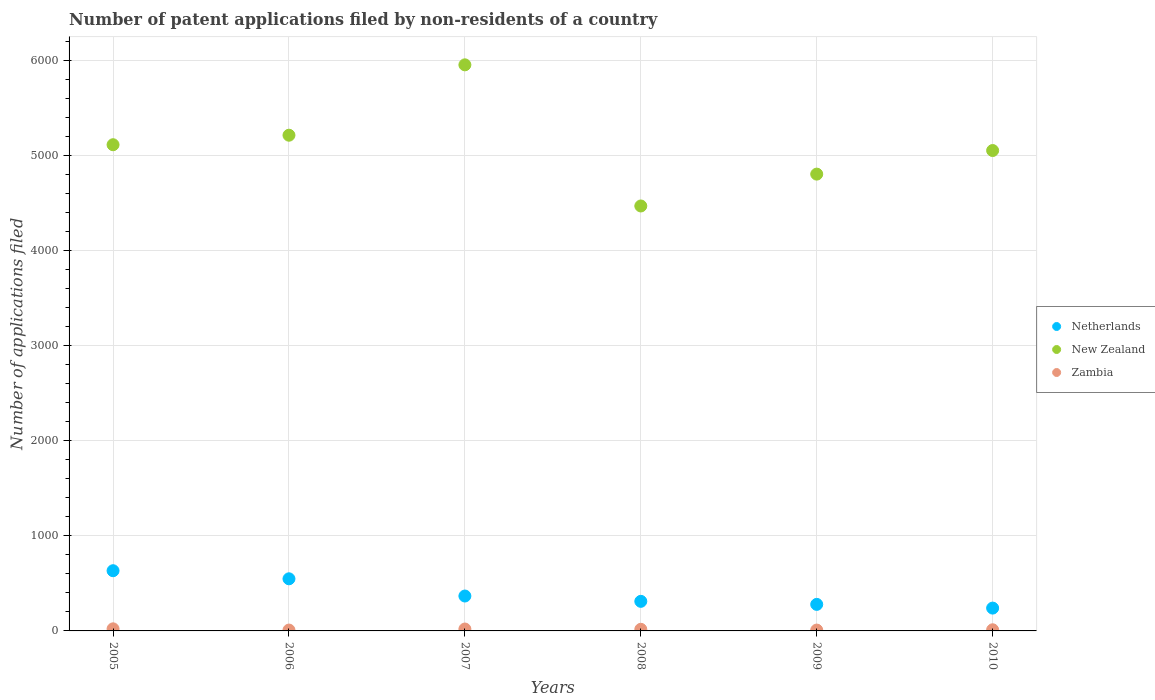Is the number of dotlines equal to the number of legend labels?
Offer a very short reply. Yes. What is the number of applications filed in New Zealand in 2005?
Provide a short and direct response. 5112. Across all years, what is the maximum number of applications filed in Netherlands?
Your answer should be compact. 633. Across all years, what is the minimum number of applications filed in Netherlands?
Provide a short and direct response. 240. What is the total number of applications filed in Netherlands in the graph?
Keep it short and to the point. 2378. What is the difference between the number of applications filed in New Zealand in 2005 and that in 2006?
Offer a terse response. -100. What is the difference between the number of applications filed in New Zealand in 2008 and the number of applications filed in Netherlands in 2007?
Give a very brief answer. 4101. What is the average number of applications filed in New Zealand per year?
Your answer should be compact. 5099.67. In the year 2009, what is the difference between the number of applications filed in Netherlands and number of applications filed in Zambia?
Give a very brief answer. 270. In how many years, is the number of applications filed in Zambia greater than 600?
Your answer should be very brief. 0. What is the ratio of the number of applications filed in Zambia in 2006 to that in 2010?
Your response must be concise. 0.75. What is the difference between the highest and the lowest number of applications filed in Netherlands?
Keep it short and to the point. 393. Is it the case that in every year, the sum of the number of applications filed in Zambia and number of applications filed in New Zealand  is greater than the number of applications filed in Netherlands?
Offer a very short reply. Yes. Does the number of applications filed in Netherlands monotonically increase over the years?
Offer a very short reply. No. Is the number of applications filed in Netherlands strictly less than the number of applications filed in Zambia over the years?
Provide a succinct answer. No. Are the values on the major ticks of Y-axis written in scientific E-notation?
Ensure brevity in your answer.  No. Does the graph contain any zero values?
Ensure brevity in your answer.  No. Does the graph contain grids?
Provide a succinct answer. Yes. How are the legend labels stacked?
Give a very brief answer. Vertical. What is the title of the graph?
Your answer should be compact. Number of patent applications filed by non-residents of a country. Does "Eritrea" appear as one of the legend labels in the graph?
Your answer should be compact. No. What is the label or title of the X-axis?
Provide a succinct answer. Years. What is the label or title of the Y-axis?
Give a very brief answer. Number of applications filed. What is the Number of applications filed in Netherlands in 2005?
Make the answer very short. 633. What is the Number of applications filed in New Zealand in 2005?
Your answer should be very brief. 5112. What is the Number of applications filed of Zambia in 2005?
Give a very brief answer. 22. What is the Number of applications filed in Netherlands in 2006?
Keep it short and to the point. 548. What is the Number of applications filed in New Zealand in 2006?
Provide a succinct answer. 5212. What is the Number of applications filed in Netherlands in 2007?
Your answer should be very brief. 367. What is the Number of applications filed of New Zealand in 2007?
Provide a succinct answer. 5952. What is the Number of applications filed in Zambia in 2007?
Keep it short and to the point. 20. What is the Number of applications filed of Netherlands in 2008?
Give a very brief answer. 311. What is the Number of applications filed of New Zealand in 2008?
Provide a short and direct response. 4468. What is the Number of applications filed in Zambia in 2008?
Provide a short and direct response. 17. What is the Number of applications filed in Netherlands in 2009?
Give a very brief answer. 279. What is the Number of applications filed of New Zealand in 2009?
Provide a short and direct response. 4803. What is the Number of applications filed in Netherlands in 2010?
Offer a very short reply. 240. What is the Number of applications filed of New Zealand in 2010?
Provide a succinct answer. 5051. Across all years, what is the maximum Number of applications filed in Netherlands?
Your answer should be compact. 633. Across all years, what is the maximum Number of applications filed of New Zealand?
Your response must be concise. 5952. Across all years, what is the maximum Number of applications filed in Zambia?
Your answer should be compact. 22. Across all years, what is the minimum Number of applications filed of Netherlands?
Provide a succinct answer. 240. Across all years, what is the minimum Number of applications filed of New Zealand?
Your response must be concise. 4468. What is the total Number of applications filed in Netherlands in the graph?
Provide a succinct answer. 2378. What is the total Number of applications filed of New Zealand in the graph?
Ensure brevity in your answer.  3.06e+04. What is the total Number of applications filed of Zambia in the graph?
Keep it short and to the point. 89. What is the difference between the Number of applications filed of Netherlands in 2005 and that in 2006?
Provide a succinct answer. 85. What is the difference between the Number of applications filed in New Zealand in 2005 and that in 2006?
Keep it short and to the point. -100. What is the difference between the Number of applications filed in Netherlands in 2005 and that in 2007?
Give a very brief answer. 266. What is the difference between the Number of applications filed of New Zealand in 2005 and that in 2007?
Your answer should be very brief. -840. What is the difference between the Number of applications filed of Netherlands in 2005 and that in 2008?
Offer a very short reply. 322. What is the difference between the Number of applications filed in New Zealand in 2005 and that in 2008?
Your answer should be very brief. 644. What is the difference between the Number of applications filed of Netherlands in 2005 and that in 2009?
Ensure brevity in your answer.  354. What is the difference between the Number of applications filed in New Zealand in 2005 and that in 2009?
Keep it short and to the point. 309. What is the difference between the Number of applications filed of Netherlands in 2005 and that in 2010?
Offer a terse response. 393. What is the difference between the Number of applications filed in Netherlands in 2006 and that in 2007?
Your answer should be very brief. 181. What is the difference between the Number of applications filed in New Zealand in 2006 and that in 2007?
Provide a succinct answer. -740. What is the difference between the Number of applications filed of Netherlands in 2006 and that in 2008?
Provide a short and direct response. 237. What is the difference between the Number of applications filed in New Zealand in 2006 and that in 2008?
Keep it short and to the point. 744. What is the difference between the Number of applications filed in Zambia in 2006 and that in 2008?
Offer a very short reply. -8. What is the difference between the Number of applications filed in Netherlands in 2006 and that in 2009?
Offer a very short reply. 269. What is the difference between the Number of applications filed of New Zealand in 2006 and that in 2009?
Offer a terse response. 409. What is the difference between the Number of applications filed in Zambia in 2006 and that in 2009?
Make the answer very short. 0. What is the difference between the Number of applications filed in Netherlands in 2006 and that in 2010?
Your answer should be compact. 308. What is the difference between the Number of applications filed in New Zealand in 2006 and that in 2010?
Your answer should be compact. 161. What is the difference between the Number of applications filed of Zambia in 2006 and that in 2010?
Give a very brief answer. -3. What is the difference between the Number of applications filed of Netherlands in 2007 and that in 2008?
Keep it short and to the point. 56. What is the difference between the Number of applications filed of New Zealand in 2007 and that in 2008?
Your response must be concise. 1484. What is the difference between the Number of applications filed of Zambia in 2007 and that in 2008?
Keep it short and to the point. 3. What is the difference between the Number of applications filed in New Zealand in 2007 and that in 2009?
Your answer should be compact. 1149. What is the difference between the Number of applications filed of Netherlands in 2007 and that in 2010?
Provide a short and direct response. 127. What is the difference between the Number of applications filed of New Zealand in 2007 and that in 2010?
Your response must be concise. 901. What is the difference between the Number of applications filed of New Zealand in 2008 and that in 2009?
Offer a very short reply. -335. What is the difference between the Number of applications filed in Zambia in 2008 and that in 2009?
Your answer should be compact. 8. What is the difference between the Number of applications filed in New Zealand in 2008 and that in 2010?
Provide a short and direct response. -583. What is the difference between the Number of applications filed of Zambia in 2008 and that in 2010?
Make the answer very short. 5. What is the difference between the Number of applications filed in New Zealand in 2009 and that in 2010?
Provide a succinct answer. -248. What is the difference between the Number of applications filed in Netherlands in 2005 and the Number of applications filed in New Zealand in 2006?
Give a very brief answer. -4579. What is the difference between the Number of applications filed of Netherlands in 2005 and the Number of applications filed of Zambia in 2006?
Your response must be concise. 624. What is the difference between the Number of applications filed in New Zealand in 2005 and the Number of applications filed in Zambia in 2006?
Your answer should be very brief. 5103. What is the difference between the Number of applications filed of Netherlands in 2005 and the Number of applications filed of New Zealand in 2007?
Offer a terse response. -5319. What is the difference between the Number of applications filed of Netherlands in 2005 and the Number of applications filed of Zambia in 2007?
Keep it short and to the point. 613. What is the difference between the Number of applications filed of New Zealand in 2005 and the Number of applications filed of Zambia in 2007?
Provide a short and direct response. 5092. What is the difference between the Number of applications filed of Netherlands in 2005 and the Number of applications filed of New Zealand in 2008?
Make the answer very short. -3835. What is the difference between the Number of applications filed of Netherlands in 2005 and the Number of applications filed of Zambia in 2008?
Your answer should be compact. 616. What is the difference between the Number of applications filed of New Zealand in 2005 and the Number of applications filed of Zambia in 2008?
Make the answer very short. 5095. What is the difference between the Number of applications filed of Netherlands in 2005 and the Number of applications filed of New Zealand in 2009?
Give a very brief answer. -4170. What is the difference between the Number of applications filed of Netherlands in 2005 and the Number of applications filed of Zambia in 2009?
Your response must be concise. 624. What is the difference between the Number of applications filed of New Zealand in 2005 and the Number of applications filed of Zambia in 2009?
Offer a terse response. 5103. What is the difference between the Number of applications filed in Netherlands in 2005 and the Number of applications filed in New Zealand in 2010?
Make the answer very short. -4418. What is the difference between the Number of applications filed in Netherlands in 2005 and the Number of applications filed in Zambia in 2010?
Your answer should be very brief. 621. What is the difference between the Number of applications filed of New Zealand in 2005 and the Number of applications filed of Zambia in 2010?
Offer a terse response. 5100. What is the difference between the Number of applications filed in Netherlands in 2006 and the Number of applications filed in New Zealand in 2007?
Your answer should be compact. -5404. What is the difference between the Number of applications filed of Netherlands in 2006 and the Number of applications filed of Zambia in 2007?
Your answer should be very brief. 528. What is the difference between the Number of applications filed in New Zealand in 2006 and the Number of applications filed in Zambia in 2007?
Your response must be concise. 5192. What is the difference between the Number of applications filed in Netherlands in 2006 and the Number of applications filed in New Zealand in 2008?
Your response must be concise. -3920. What is the difference between the Number of applications filed of Netherlands in 2006 and the Number of applications filed of Zambia in 2008?
Your answer should be compact. 531. What is the difference between the Number of applications filed of New Zealand in 2006 and the Number of applications filed of Zambia in 2008?
Provide a succinct answer. 5195. What is the difference between the Number of applications filed in Netherlands in 2006 and the Number of applications filed in New Zealand in 2009?
Keep it short and to the point. -4255. What is the difference between the Number of applications filed of Netherlands in 2006 and the Number of applications filed of Zambia in 2009?
Keep it short and to the point. 539. What is the difference between the Number of applications filed in New Zealand in 2006 and the Number of applications filed in Zambia in 2009?
Keep it short and to the point. 5203. What is the difference between the Number of applications filed of Netherlands in 2006 and the Number of applications filed of New Zealand in 2010?
Your response must be concise. -4503. What is the difference between the Number of applications filed in Netherlands in 2006 and the Number of applications filed in Zambia in 2010?
Provide a succinct answer. 536. What is the difference between the Number of applications filed of New Zealand in 2006 and the Number of applications filed of Zambia in 2010?
Provide a succinct answer. 5200. What is the difference between the Number of applications filed in Netherlands in 2007 and the Number of applications filed in New Zealand in 2008?
Keep it short and to the point. -4101. What is the difference between the Number of applications filed in Netherlands in 2007 and the Number of applications filed in Zambia in 2008?
Your response must be concise. 350. What is the difference between the Number of applications filed of New Zealand in 2007 and the Number of applications filed of Zambia in 2008?
Make the answer very short. 5935. What is the difference between the Number of applications filed in Netherlands in 2007 and the Number of applications filed in New Zealand in 2009?
Offer a very short reply. -4436. What is the difference between the Number of applications filed of Netherlands in 2007 and the Number of applications filed of Zambia in 2009?
Provide a short and direct response. 358. What is the difference between the Number of applications filed of New Zealand in 2007 and the Number of applications filed of Zambia in 2009?
Offer a very short reply. 5943. What is the difference between the Number of applications filed in Netherlands in 2007 and the Number of applications filed in New Zealand in 2010?
Your answer should be very brief. -4684. What is the difference between the Number of applications filed of Netherlands in 2007 and the Number of applications filed of Zambia in 2010?
Make the answer very short. 355. What is the difference between the Number of applications filed in New Zealand in 2007 and the Number of applications filed in Zambia in 2010?
Offer a terse response. 5940. What is the difference between the Number of applications filed in Netherlands in 2008 and the Number of applications filed in New Zealand in 2009?
Your answer should be compact. -4492. What is the difference between the Number of applications filed of Netherlands in 2008 and the Number of applications filed of Zambia in 2009?
Offer a very short reply. 302. What is the difference between the Number of applications filed of New Zealand in 2008 and the Number of applications filed of Zambia in 2009?
Your response must be concise. 4459. What is the difference between the Number of applications filed of Netherlands in 2008 and the Number of applications filed of New Zealand in 2010?
Your answer should be very brief. -4740. What is the difference between the Number of applications filed of Netherlands in 2008 and the Number of applications filed of Zambia in 2010?
Your response must be concise. 299. What is the difference between the Number of applications filed of New Zealand in 2008 and the Number of applications filed of Zambia in 2010?
Your answer should be very brief. 4456. What is the difference between the Number of applications filed in Netherlands in 2009 and the Number of applications filed in New Zealand in 2010?
Keep it short and to the point. -4772. What is the difference between the Number of applications filed of Netherlands in 2009 and the Number of applications filed of Zambia in 2010?
Give a very brief answer. 267. What is the difference between the Number of applications filed in New Zealand in 2009 and the Number of applications filed in Zambia in 2010?
Keep it short and to the point. 4791. What is the average Number of applications filed of Netherlands per year?
Provide a succinct answer. 396.33. What is the average Number of applications filed in New Zealand per year?
Ensure brevity in your answer.  5099.67. What is the average Number of applications filed of Zambia per year?
Your answer should be very brief. 14.83. In the year 2005, what is the difference between the Number of applications filed in Netherlands and Number of applications filed in New Zealand?
Give a very brief answer. -4479. In the year 2005, what is the difference between the Number of applications filed of Netherlands and Number of applications filed of Zambia?
Ensure brevity in your answer.  611. In the year 2005, what is the difference between the Number of applications filed of New Zealand and Number of applications filed of Zambia?
Offer a terse response. 5090. In the year 2006, what is the difference between the Number of applications filed in Netherlands and Number of applications filed in New Zealand?
Offer a very short reply. -4664. In the year 2006, what is the difference between the Number of applications filed of Netherlands and Number of applications filed of Zambia?
Ensure brevity in your answer.  539. In the year 2006, what is the difference between the Number of applications filed in New Zealand and Number of applications filed in Zambia?
Ensure brevity in your answer.  5203. In the year 2007, what is the difference between the Number of applications filed of Netherlands and Number of applications filed of New Zealand?
Provide a succinct answer. -5585. In the year 2007, what is the difference between the Number of applications filed in Netherlands and Number of applications filed in Zambia?
Provide a short and direct response. 347. In the year 2007, what is the difference between the Number of applications filed in New Zealand and Number of applications filed in Zambia?
Make the answer very short. 5932. In the year 2008, what is the difference between the Number of applications filed of Netherlands and Number of applications filed of New Zealand?
Provide a succinct answer. -4157. In the year 2008, what is the difference between the Number of applications filed in Netherlands and Number of applications filed in Zambia?
Keep it short and to the point. 294. In the year 2008, what is the difference between the Number of applications filed in New Zealand and Number of applications filed in Zambia?
Your answer should be compact. 4451. In the year 2009, what is the difference between the Number of applications filed in Netherlands and Number of applications filed in New Zealand?
Offer a terse response. -4524. In the year 2009, what is the difference between the Number of applications filed of Netherlands and Number of applications filed of Zambia?
Offer a terse response. 270. In the year 2009, what is the difference between the Number of applications filed of New Zealand and Number of applications filed of Zambia?
Give a very brief answer. 4794. In the year 2010, what is the difference between the Number of applications filed of Netherlands and Number of applications filed of New Zealand?
Keep it short and to the point. -4811. In the year 2010, what is the difference between the Number of applications filed of Netherlands and Number of applications filed of Zambia?
Give a very brief answer. 228. In the year 2010, what is the difference between the Number of applications filed of New Zealand and Number of applications filed of Zambia?
Ensure brevity in your answer.  5039. What is the ratio of the Number of applications filed of Netherlands in 2005 to that in 2006?
Provide a short and direct response. 1.16. What is the ratio of the Number of applications filed of New Zealand in 2005 to that in 2006?
Make the answer very short. 0.98. What is the ratio of the Number of applications filed in Zambia in 2005 to that in 2006?
Offer a terse response. 2.44. What is the ratio of the Number of applications filed of Netherlands in 2005 to that in 2007?
Ensure brevity in your answer.  1.72. What is the ratio of the Number of applications filed in New Zealand in 2005 to that in 2007?
Offer a very short reply. 0.86. What is the ratio of the Number of applications filed of Zambia in 2005 to that in 2007?
Offer a very short reply. 1.1. What is the ratio of the Number of applications filed in Netherlands in 2005 to that in 2008?
Your answer should be very brief. 2.04. What is the ratio of the Number of applications filed of New Zealand in 2005 to that in 2008?
Your response must be concise. 1.14. What is the ratio of the Number of applications filed of Zambia in 2005 to that in 2008?
Provide a short and direct response. 1.29. What is the ratio of the Number of applications filed in Netherlands in 2005 to that in 2009?
Your response must be concise. 2.27. What is the ratio of the Number of applications filed of New Zealand in 2005 to that in 2009?
Offer a very short reply. 1.06. What is the ratio of the Number of applications filed in Zambia in 2005 to that in 2009?
Give a very brief answer. 2.44. What is the ratio of the Number of applications filed in Netherlands in 2005 to that in 2010?
Your response must be concise. 2.64. What is the ratio of the Number of applications filed in New Zealand in 2005 to that in 2010?
Give a very brief answer. 1.01. What is the ratio of the Number of applications filed in Zambia in 2005 to that in 2010?
Your response must be concise. 1.83. What is the ratio of the Number of applications filed in Netherlands in 2006 to that in 2007?
Provide a short and direct response. 1.49. What is the ratio of the Number of applications filed of New Zealand in 2006 to that in 2007?
Make the answer very short. 0.88. What is the ratio of the Number of applications filed in Zambia in 2006 to that in 2007?
Provide a succinct answer. 0.45. What is the ratio of the Number of applications filed in Netherlands in 2006 to that in 2008?
Give a very brief answer. 1.76. What is the ratio of the Number of applications filed in New Zealand in 2006 to that in 2008?
Provide a short and direct response. 1.17. What is the ratio of the Number of applications filed of Zambia in 2006 to that in 2008?
Ensure brevity in your answer.  0.53. What is the ratio of the Number of applications filed of Netherlands in 2006 to that in 2009?
Your response must be concise. 1.96. What is the ratio of the Number of applications filed of New Zealand in 2006 to that in 2009?
Your response must be concise. 1.09. What is the ratio of the Number of applications filed of Zambia in 2006 to that in 2009?
Keep it short and to the point. 1. What is the ratio of the Number of applications filed of Netherlands in 2006 to that in 2010?
Your answer should be compact. 2.28. What is the ratio of the Number of applications filed in New Zealand in 2006 to that in 2010?
Make the answer very short. 1.03. What is the ratio of the Number of applications filed of Zambia in 2006 to that in 2010?
Your answer should be very brief. 0.75. What is the ratio of the Number of applications filed of Netherlands in 2007 to that in 2008?
Offer a terse response. 1.18. What is the ratio of the Number of applications filed in New Zealand in 2007 to that in 2008?
Give a very brief answer. 1.33. What is the ratio of the Number of applications filed of Zambia in 2007 to that in 2008?
Ensure brevity in your answer.  1.18. What is the ratio of the Number of applications filed in Netherlands in 2007 to that in 2009?
Ensure brevity in your answer.  1.32. What is the ratio of the Number of applications filed in New Zealand in 2007 to that in 2009?
Your answer should be compact. 1.24. What is the ratio of the Number of applications filed in Zambia in 2007 to that in 2009?
Your response must be concise. 2.22. What is the ratio of the Number of applications filed of Netherlands in 2007 to that in 2010?
Give a very brief answer. 1.53. What is the ratio of the Number of applications filed of New Zealand in 2007 to that in 2010?
Your answer should be very brief. 1.18. What is the ratio of the Number of applications filed in Netherlands in 2008 to that in 2009?
Give a very brief answer. 1.11. What is the ratio of the Number of applications filed of New Zealand in 2008 to that in 2009?
Make the answer very short. 0.93. What is the ratio of the Number of applications filed of Zambia in 2008 to that in 2009?
Give a very brief answer. 1.89. What is the ratio of the Number of applications filed in Netherlands in 2008 to that in 2010?
Make the answer very short. 1.3. What is the ratio of the Number of applications filed in New Zealand in 2008 to that in 2010?
Ensure brevity in your answer.  0.88. What is the ratio of the Number of applications filed of Zambia in 2008 to that in 2010?
Provide a succinct answer. 1.42. What is the ratio of the Number of applications filed of Netherlands in 2009 to that in 2010?
Make the answer very short. 1.16. What is the ratio of the Number of applications filed of New Zealand in 2009 to that in 2010?
Keep it short and to the point. 0.95. What is the ratio of the Number of applications filed of Zambia in 2009 to that in 2010?
Provide a succinct answer. 0.75. What is the difference between the highest and the second highest Number of applications filed in New Zealand?
Provide a succinct answer. 740. What is the difference between the highest and the lowest Number of applications filed in Netherlands?
Make the answer very short. 393. What is the difference between the highest and the lowest Number of applications filed in New Zealand?
Keep it short and to the point. 1484. What is the difference between the highest and the lowest Number of applications filed in Zambia?
Offer a very short reply. 13. 